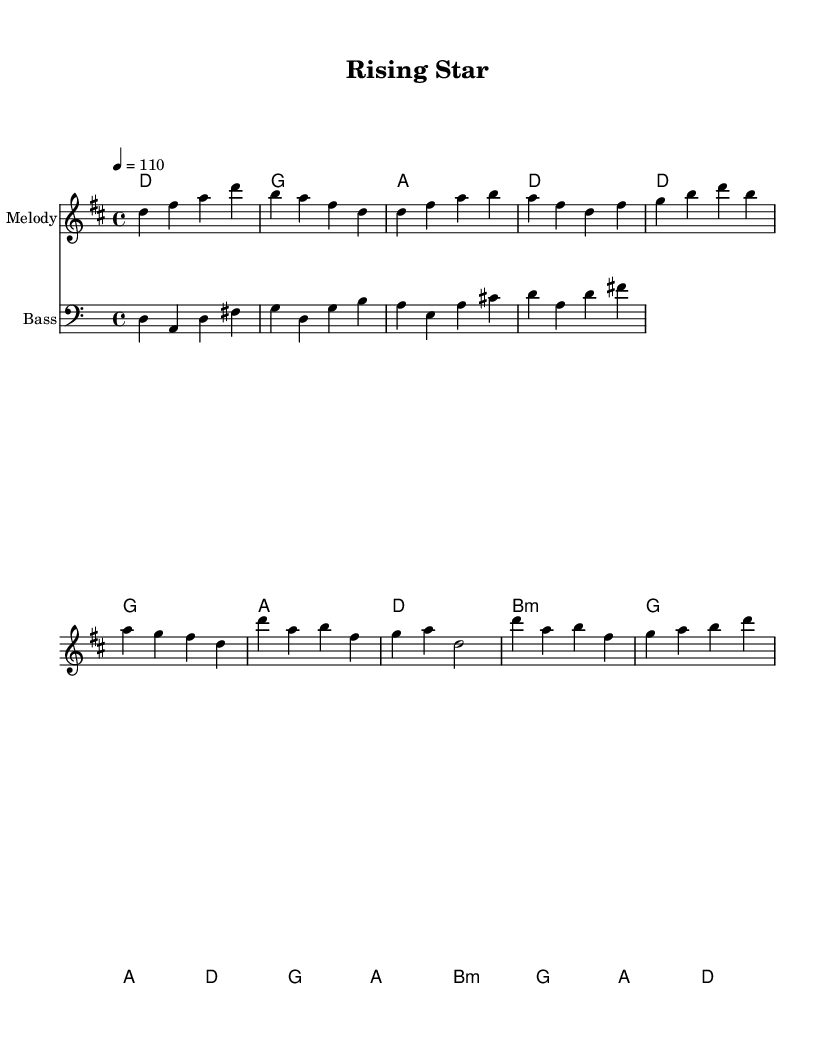What is the key signature of this music? The key signature is indicated at the beginning of the staff and shows two sharps, which corresponds to D major.
Answer: D major What is the time signature of this music? The time signature is located at the beginning of the score and is written as 4/4, indicating four beats in a measure and the quarter note gets one beat.
Answer: 4/4 What is the tempo marking for this piece? The tempo marking can be found at the beginning of the score, and it indicates a tempo of 110 beats per minute.
Answer: 110 How many bars are in the chorus? The chorus section consists of two lines, each having two measures. Counting these gives a total of four measures in the chorus.
Answer: 4 What chord is used in the first measure of the verse? The first measure of the verse shows the chord D major, as indicated in the harmonies section.
Answer: D Which genre does this piece belong to? The music is characterized by its rhythmic groove and upbeat feel, typical of funk music, which focuses on a strong bass line and rhythmic patterns.
Answer: Funk How does the melody start? The melody starts with the note D in the first measure, as noted in the relative melody line.
Answer: D 